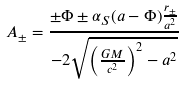Convert formula to latex. <formula><loc_0><loc_0><loc_500><loc_500>A _ { \pm } = \frac { \pm \Phi \pm \alpha _ { S } ( a - \Phi ) \frac { r _ { \pm } } { a ^ { 2 } } } { - 2 \sqrt { \left ( \frac { G M } { c ^ { 2 } } \right ) ^ { 2 } - a ^ { 2 } } }</formula> 